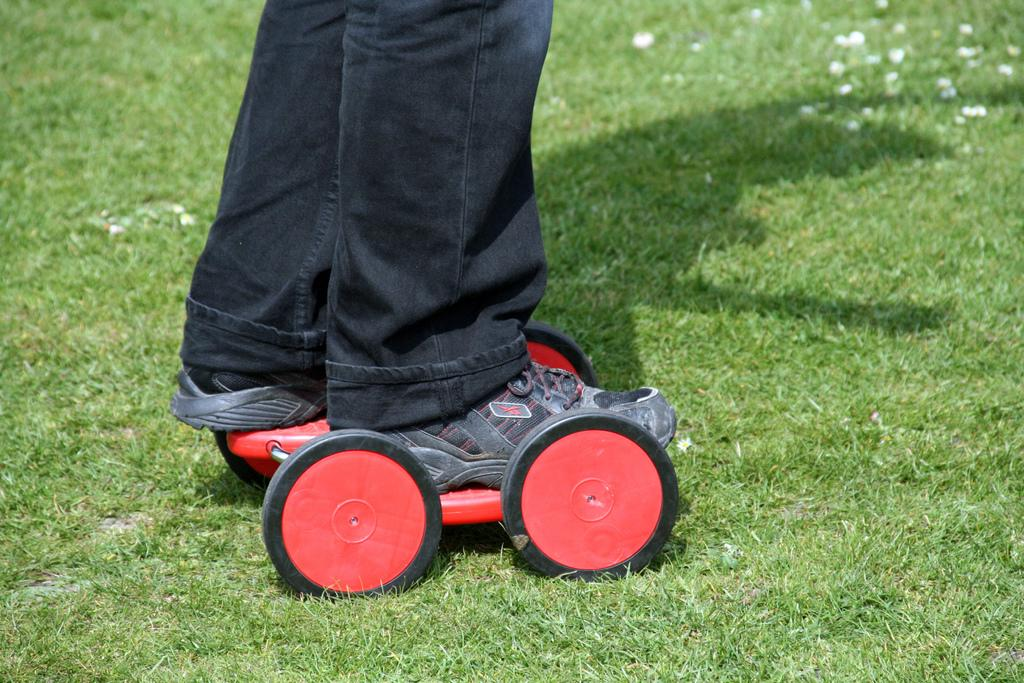What is present in the image? There is a person in the image. What type of natural environment can be seen in the image? There is grass visible in the image. What type of basin is the person using in the image? There is no basin present in the image. What type of card is the person holding in the image? There is no card present in the image. What type of suit is the person wearing in the image? There is no suit present in the image, and the person's clothing is not described in the provided facts. 